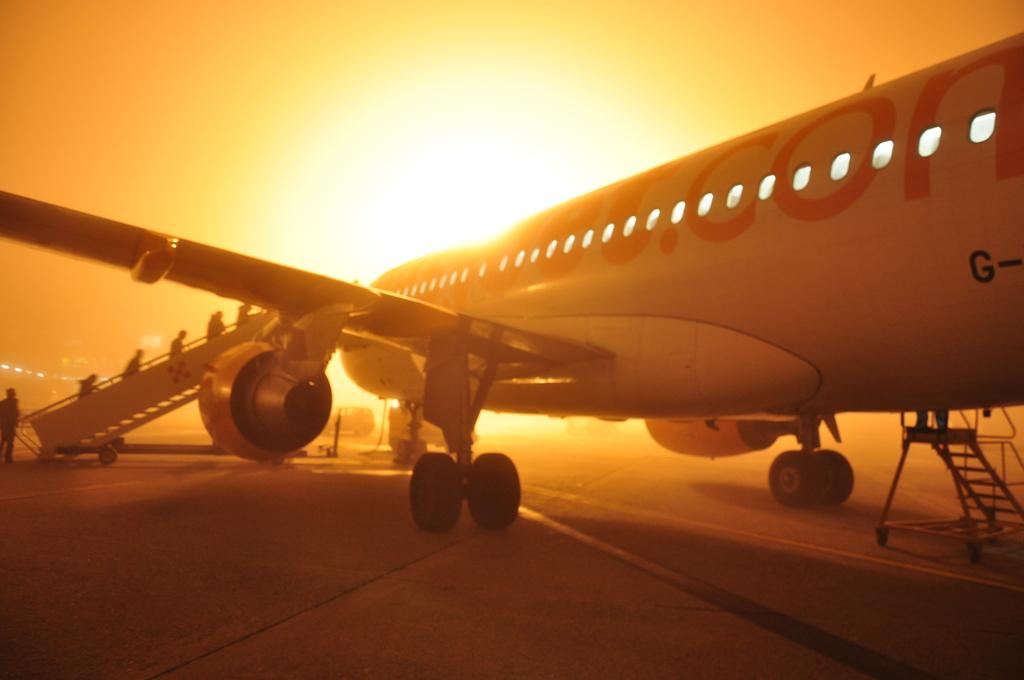What is the main subject of the image? The main subject of the image is a plane. Can you describe anything in the background of the image? Yes, there is a vehicle in the background of the image. What activity is taking place on the left side of the image? There are people climbing stairs on the left side of the image. What is visible at the top of the image? The sky is visible at the top of the image, and the sun is observable in the sky. How many matches are being used by the hen in the image? There is no hen or matches present in the image. What type of step is being taken by the people climbing stairs in the image? The image does not specify the type of step being taken by the people climbing stairs; it only shows them climbing. 